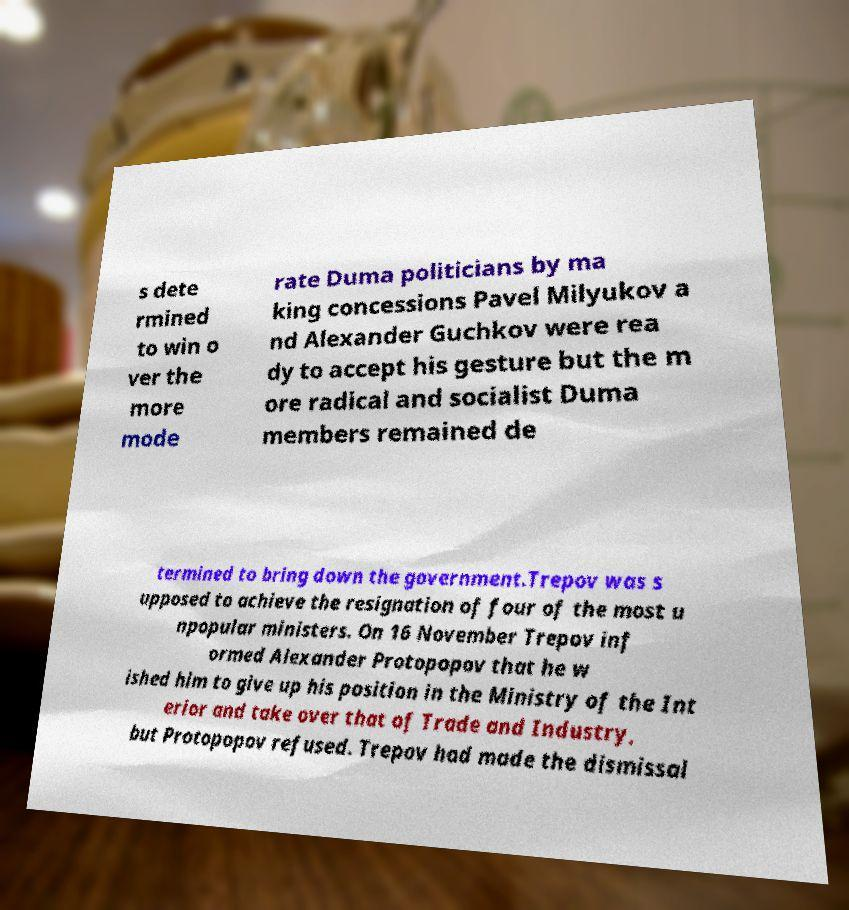What messages or text are displayed in this image? I need them in a readable, typed format. s dete rmined to win o ver the more mode rate Duma politicians by ma king concessions Pavel Milyukov a nd Alexander Guchkov were rea dy to accept his gesture but the m ore radical and socialist Duma members remained de termined to bring down the government.Trepov was s upposed to achieve the resignation of four of the most u npopular ministers. On 16 November Trepov inf ormed Alexander Protopopov that he w ished him to give up his position in the Ministry of the Int erior and take over that of Trade and Industry, but Protopopov refused. Trepov had made the dismissal 